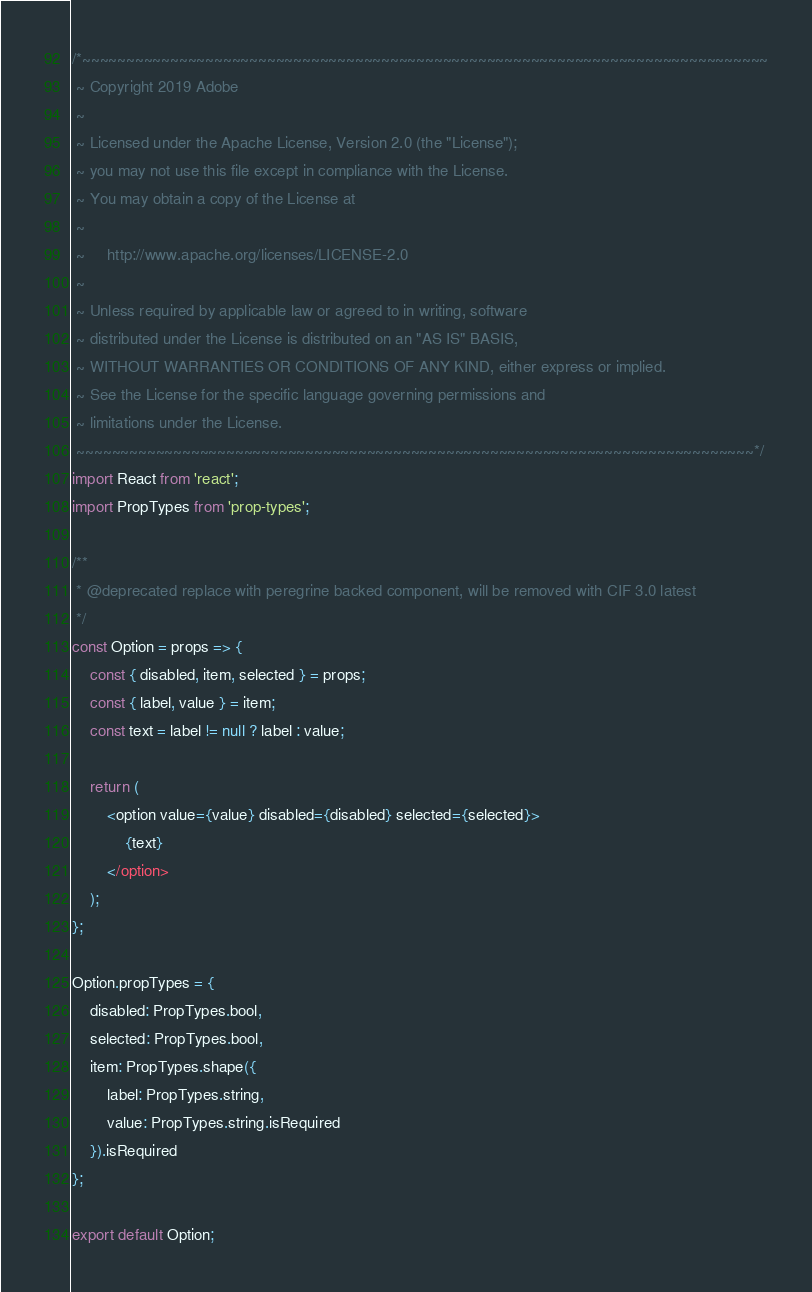<code> <loc_0><loc_0><loc_500><loc_500><_JavaScript_>/*~~~~~~~~~~~~~~~~~~~~~~~~~~~~~~~~~~~~~~~~~~~~~~~~~~~~~~~~~~~~~~~~~~~~~~~~~~~~~~
 ~ Copyright 2019 Adobe
 ~
 ~ Licensed under the Apache License, Version 2.0 (the "License");
 ~ you may not use this file except in compliance with the License.
 ~ You may obtain a copy of the License at
 ~
 ~     http://www.apache.org/licenses/LICENSE-2.0
 ~
 ~ Unless required by applicable law or agreed to in writing, software
 ~ distributed under the License is distributed on an "AS IS" BASIS,
 ~ WITHOUT WARRANTIES OR CONDITIONS OF ANY KIND, either express or implied.
 ~ See the License for the specific language governing permissions and
 ~ limitations under the License.
 ~~~~~~~~~~~~~~~~~~~~~~~~~~~~~~~~~~~~~~~~~~~~~~~~~~~~~~~~~~~~~~~~~~~~~~~~~~~~~*/
import React from 'react';
import PropTypes from 'prop-types';

/**
 * @deprecated replace with peregrine backed component, will be removed with CIF 3.0 latest
 */
const Option = props => {
    const { disabled, item, selected } = props;
    const { label, value } = item;
    const text = label != null ? label : value;

    return (
        <option value={value} disabled={disabled} selected={selected}>
            {text}
        </option>
    );
};

Option.propTypes = {
    disabled: PropTypes.bool,
    selected: PropTypes.bool,
    item: PropTypes.shape({
        label: PropTypes.string,
        value: PropTypes.string.isRequired
    }).isRequired
};

export default Option;
</code> 